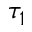Convert formula to latex. <formula><loc_0><loc_0><loc_500><loc_500>\tau _ { 1 }</formula> 